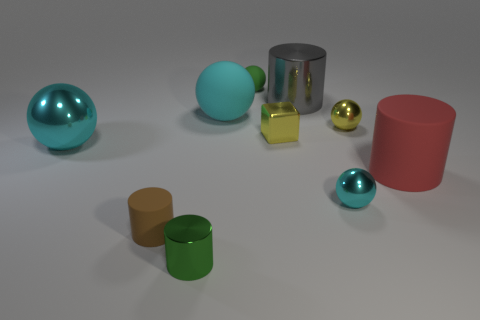How many cyan balls must be subtracted to get 1 cyan balls? 2 Subtract all purple cylinders. How many cyan spheres are left? 3 Subtract all cyan matte balls. How many balls are left? 4 Subtract 1 cylinders. How many cylinders are left? 3 Subtract all yellow balls. How many balls are left? 4 Subtract all red balls. Subtract all yellow cylinders. How many balls are left? 5 Subtract all cylinders. How many objects are left? 6 Add 4 yellow cubes. How many yellow cubes exist? 5 Subtract 0 gray balls. How many objects are left? 10 Subtract all big matte spheres. Subtract all small metallic things. How many objects are left? 5 